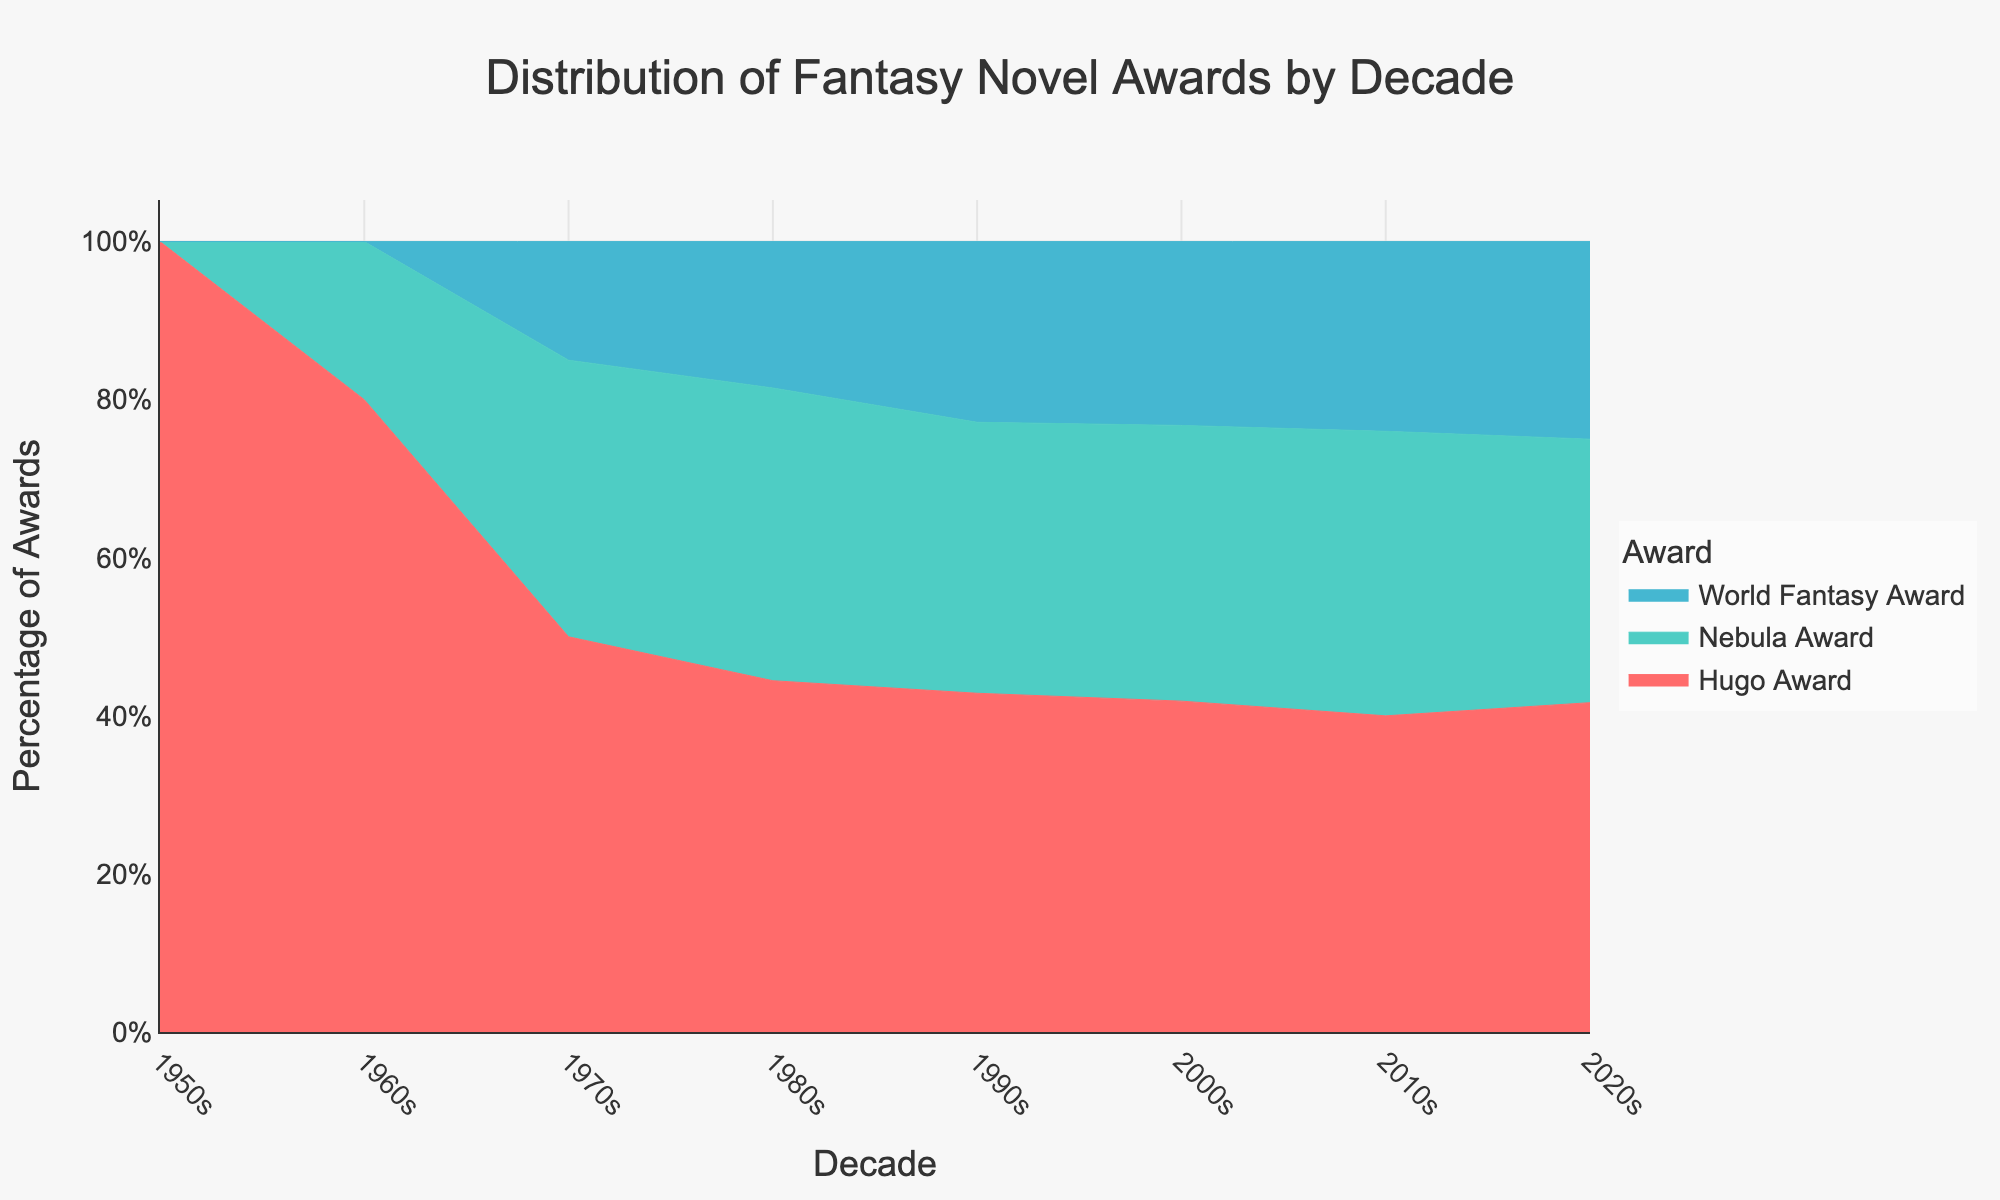What is the title of the area chart? The title of the area chart is prominently displayed at the top of the figure.
Answer: Distribution of Fantasy Novel Awards by Decade How many different awards are represented in the area chart? There are different colored segments (bands) in the chart representing each award.
Answer: 3 Which decade shows the highest percentage of Hugo Awards? By observing the distribution of the Hugo Awards in the area chart, the highest segment can be identified.
Answer: 2010s Compare the total number of awards in the 1950s and 2020s. Which decade had more awards? Sum the awards for each decade and compare: 1950s had 5 Hugo Awards, 2020s had (5+4+3) = 12 awards.
Answer: 2020s Has the percentage of Nebula Awards increased or decreased from the 1970s to the 2010s? Compare the height of the Nebula Awards segment between the 1970s and the 2010s; it has increased from 1970s (7) to 2010s (18).
Answer: Increased When were World Fantasy Awards first introduced according to the chart? The start of the colored segment for the World Fantasy Award in the chart indicates its introduction time.
Answer: 1970s In which decade did the total number of awards peak? The tallest combined stack in the area chart indicates the peak decade for awards; 2010s had (20+18+12) = 50 awards, the peak.
Answer: 2010s What is the trend for Hugo Awards from the 1950s to the 2010s? Observe the changes in the height of the Hugo Awards segment through the decades: increasing trend from 1950s (5) to 2010s (20).
Answer: Increasing Which award had the smallest number in the 2000s? By checking the height of each segment in the 2000s: World Fantasy Award segment is the smallest in the 2000s (10).
Answer: World Fantasy Award 